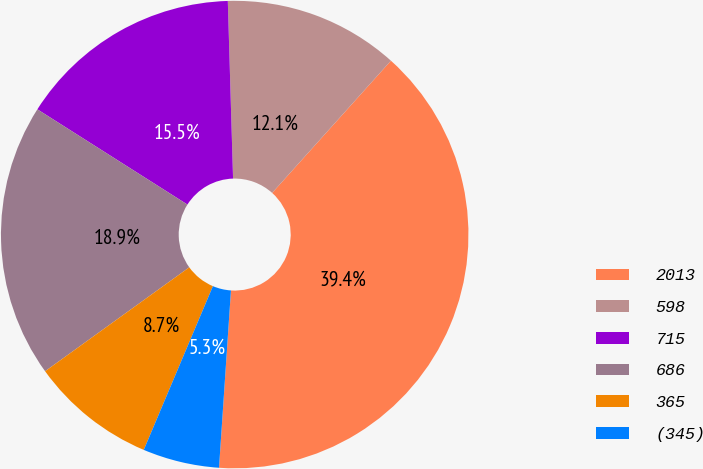<chart> <loc_0><loc_0><loc_500><loc_500><pie_chart><fcel>2013<fcel>598<fcel>715<fcel>686<fcel>365<fcel>(345)<nl><fcel>39.42%<fcel>12.12%<fcel>15.53%<fcel>18.94%<fcel>8.7%<fcel>5.29%<nl></chart> 